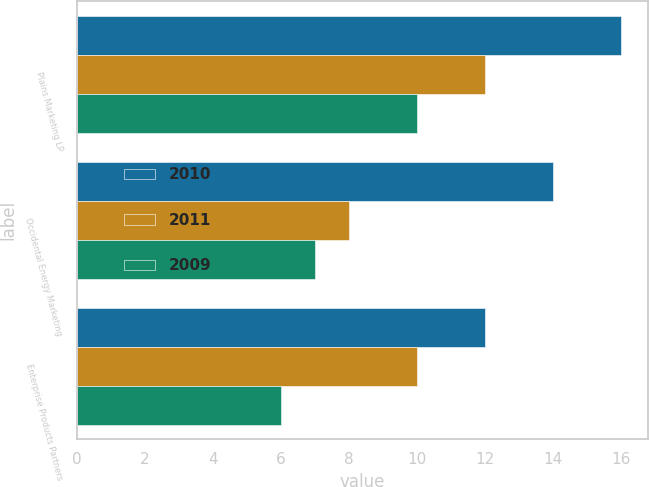Convert chart to OTSL. <chart><loc_0><loc_0><loc_500><loc_500><stacked_bar_chart><ecel><fcel>Plains Marketing LP<fcel>Occidental Energy Marketing<fcel>Enterprise Products Partners<nl><fcel>2010<fcel>16<fcel>14<fcel>12<nl><fcel>2011<fcel>12<fcel>8<fcel>10<nl><fcel>2009<fcel>10<fcel>7<fcel>6<nl></chart> 